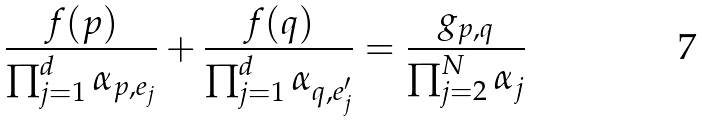<formula> <loc_0><loc_0><loc_500><loc_500>\frac { f ( p ) } { \prod _ { j = 1 } ^ { d } \alpha _ { p , e _ { j } } } + \frac { f ( q ) } { \prod _ { j = 1 } ^ { d } \alpha _ { q , e ^ { \prime } _ { j } } } = \frac { g _ { p , q } } { \prod _ { j = 2 } ^ { N } \alpha _ { j } }</formula> 